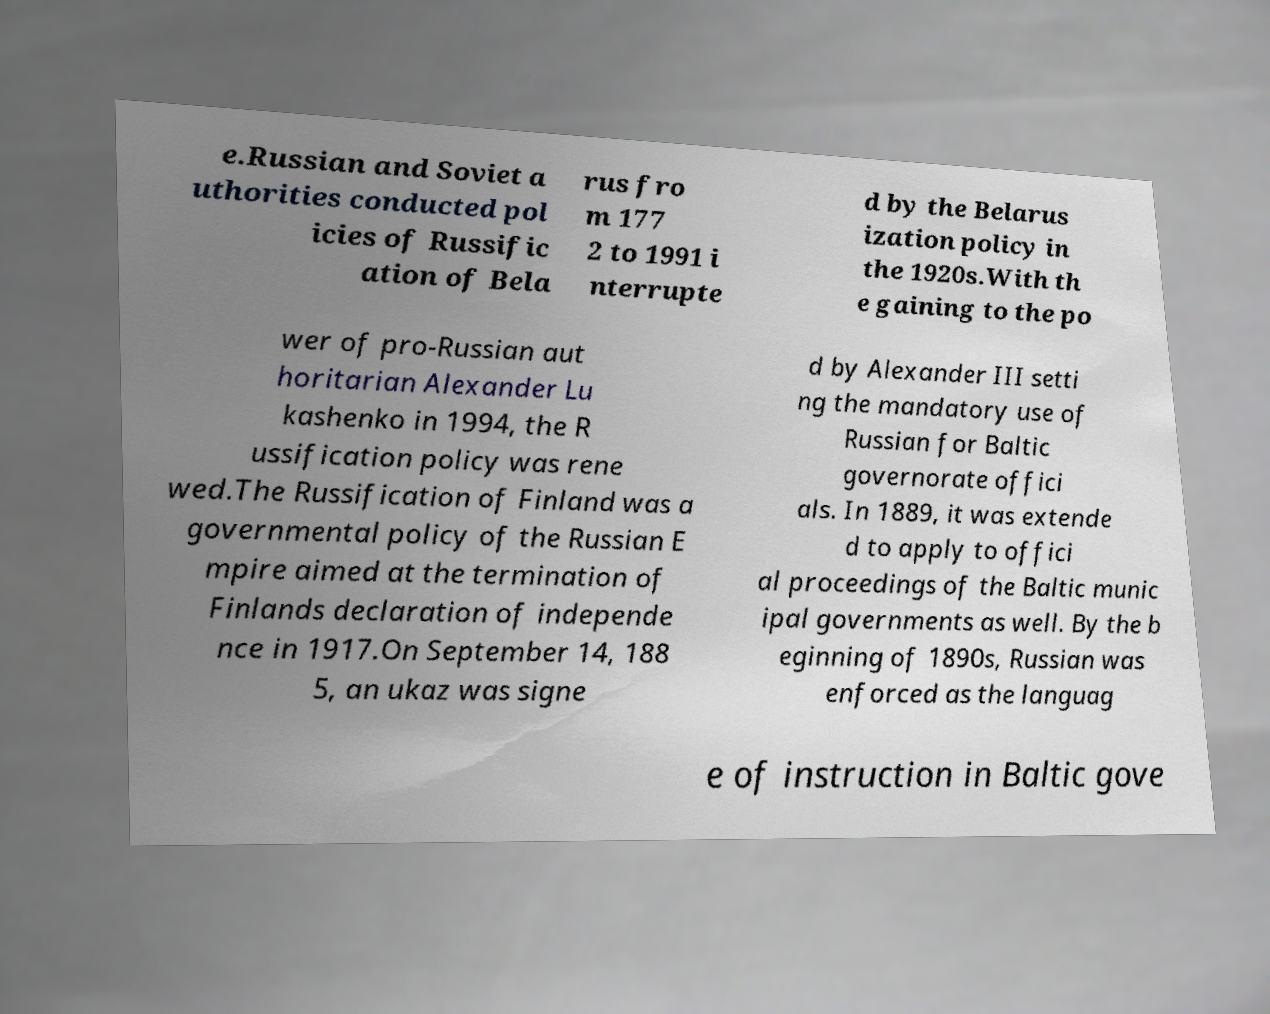Please identify and transcribe the text found in this image. e.Russian and Soviet a uthorities conducted pol icies of Russific ation of Bela rus fro m 177 2 to 1991 i nterrupte d by the Belarus ization policy in the 1920s.With th e gaining to the po wer of pro-Russian aut horitarian Alexander Lu kashenko in 1994, the R ussification policy was rene wed.The Russification of Finland was a governmental policy of the Russian E mpire aimed at the termination of Finlands declaration of independe nce in 1917.On September 14, 188 5, an ukaz was signe d by Alexander III setti ng the mandatory use of Russian for Baltic governorate offici als. In 1889, it was extende d to apply to offici al proceedings of the Baltic munic ipal governments as well. By the b eginning of 1890s, Russian was enforced as the languag e of instruction in Baltic gove 